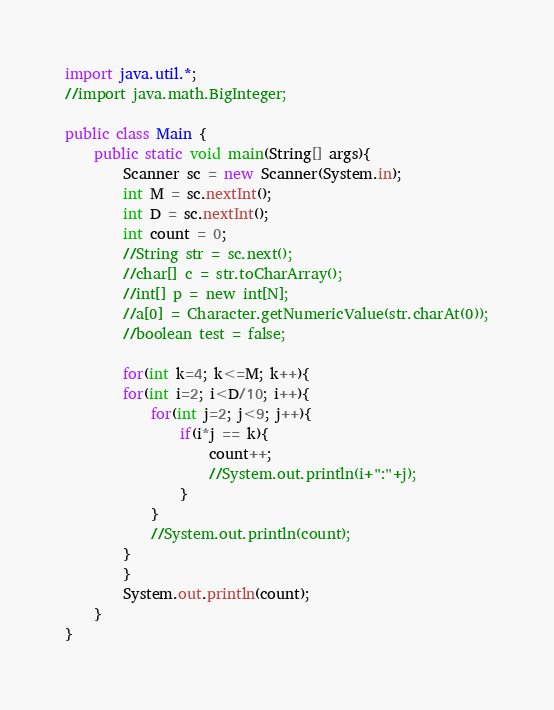<code> <loc_0><loc_0><loc_500><loc_500><_Java_>import java.util.*;
//import java.math.BigInteger;

public class Main {
    public static void main(String[] args){
        Scanner sc = new Scanner(System.in);
        int M = sc.nextInt();
        int D = sc.nextInt();
        int count = 0;
        //String str = sc.next();
        //char[] c = str.toCharArray();
        //int[] p = new int[N];
        //a[0] = Character.getNumericValue(str.charAt(0));
        //boolean test = false;
        
        for(int k=4; k<=M; k++){
        for(int i=2; i<D/10; i++){
            for(int j=2; j<9; j++){
                if(i*j == k){
                    count++;
                    //System.out.println(i+":"+j);
                }
            }
            //System.out.println(count);
        }
        }
        System.out.println(count);
    }
}
</code> 